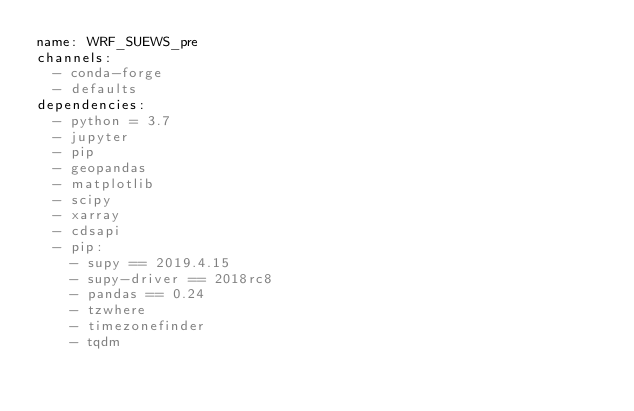Convert code to text. <code><loc_0><loc_0><loc_500><loc_500><_YAML_>name: WRF_SUEWS_pre
channels:
  - conda-forge
  - defaults
dependencies:
  - python = 3.7
  - jupyter
  - pip
  - geopandas
  - matplotlib
  - scipy
  - xarray
  - cdsapi
  - pip:
    - supy == 2019.4.15
    - supy-driver == 2018rc8
    - pandas == 0.24
    - tzwhere
    - timezonefinder
    - tqdm</code> 